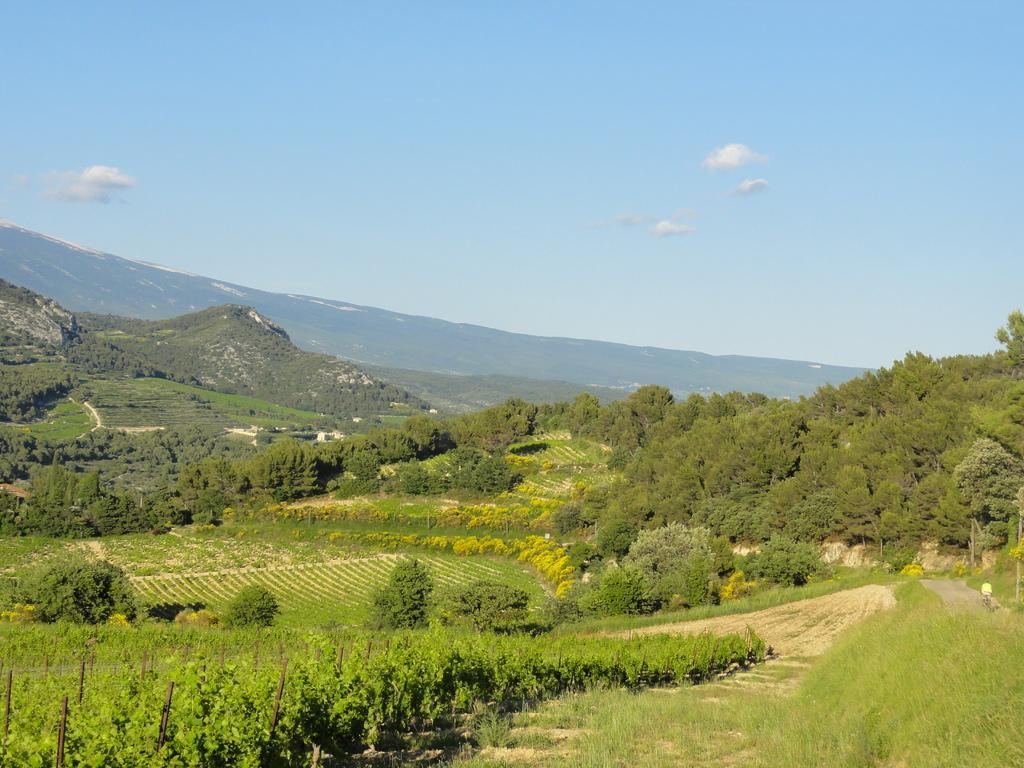Describe this image in one or two sentences. In this image we can see trees, plants, grass, hills, sky and clouds. 